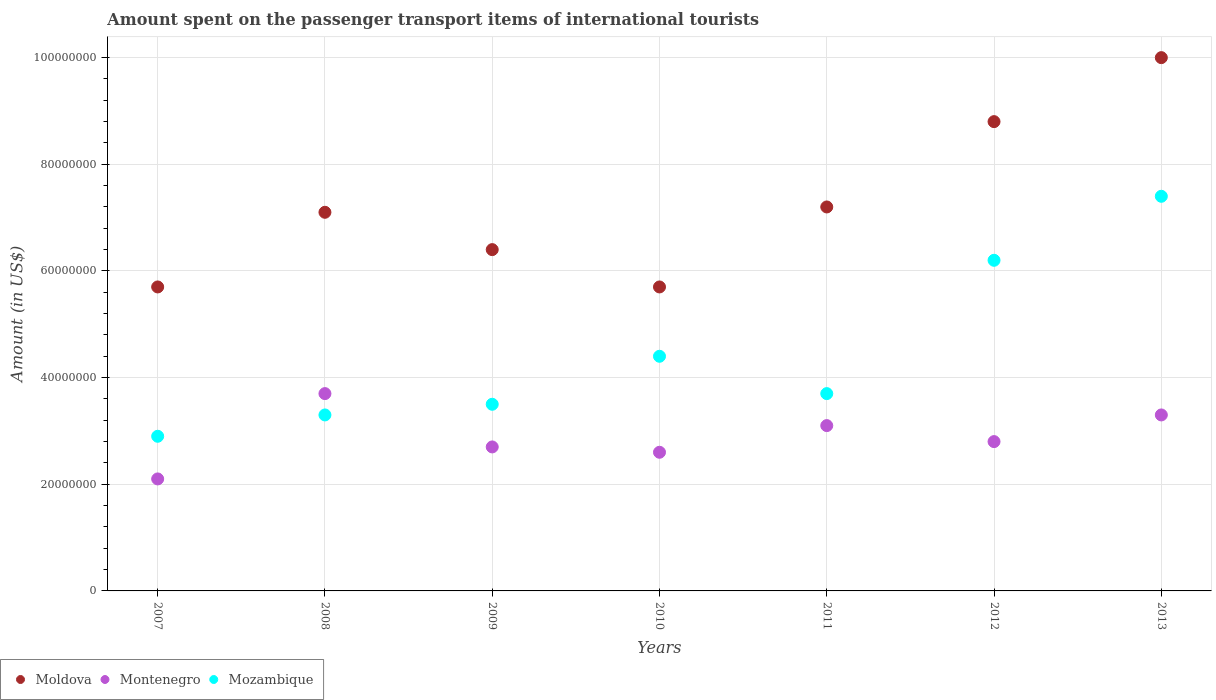Is the number of dotlines equal to the number of legend labels?
Offer a terse response. Yes. What is the amount spent on the passenger transport items of international tourists in Montenegro in 2013?
Keep it short and to the point. 3.30e+07. Across all years, what is the maximum amount spent on the passenger transport items of international tourists in Mozambique?
Offer a very short reply. 7.40e+07. Across all years, what is the minimum amount spent on the passenger transport items of international tourists in Mozambique?
Your answer should be very brief. 2.90e+07. In which year was the amount spent on the passenger transport items of international tourists in Montenegro maximum?
Your answer should be very brief. 2008. In which year was the amount spent on the passenger transport items of international tourists in Montenegro minimum?
Provide a succinct answer. 2007. What is the total amount spent on the passenger transport items of international tourists in Montenegro in the graph?
Provide a succinct answer. 2.03e+08. What is the difference between the amount spent on the passenger transport items of international tourists in Moldova in 2010 and that in 2011?
Offer a terse response. -1.50e+07. What is the difference between the amount spent on the passenger transport items of international tourists in Moldova in 2008 and the amount spent on the passenger transport items of international tourists in Montenegro in 2009?
Provide a succinct answer. 4.40e+07. What is the average amount spent on the passenger transport items of international tourists in Mozambique per year?
Keep it short and to the point. 4.49e+07. In the year 2007, what is the difference between the amount spent on the passenger transport items of international tourists in Mozambique and amount spent on the passenger transport items of international tourists in Montenegro?
Your response must be concise. 8.00e+06. In how many years, is the amount spent on the passenger transport items of international tourists in Mozambique greater than 92000000 US$?
Your answer should be very brief. 0. What is the ratio of the amount spent on the passenger transport items of international tourists in Montenegro in 2008 to that in 2009?
Offer a very short reply. 1.37. Is the amount spent on the passenger transport items of international tourists in Moldova in 2009 less than that in 2012?
Provide a short and direct response. Yes. Is the difference between the amount spent on the passenger transport items of international tourists in Mozambique in 2008 and 2010 greater than the difference between the amount spent on the passenger transport items of international tourists in Montenegro in 2008 and 2010?
Provide a short and direct response. No. What is the difference between the highest and the second highest amount spent on the passenger transport items of international tourists in Moldova?
Your answer should be very brief. 1.20e+07. What is the difference between the highest and the lowest amount spent on the passenger transport items of international tourists in Montenegro?
Offer a very short reply. 1.60e+07. Is the sum of the amount spent on the passenger transport items of international tourists in Mozambique in 2008 and 2009 greater than the maximum amount spent on the passenger transport items of international tourists in Montenegro across all years?
Ensure brevity in your answer.  Yes. Is it the case that in every year, the sum of the amount spent on the passenger transport items of international tourists in Montenegro and amount spent on the passenger transport items of international tourists in Moldova  is greater than the amount spent on the passenger transport items of international tourists in Mozambique?
Offer a very short reply. Yes. Is the amount spent on the passenger transport items of international tourists in Montenegro strictly less than the amount spent on the passenger transport items of international tourists in Mozambique over the years?
Offer a very short reply. No. Does the graph contain any zero values?
Provide a short and direct response. No. Does the graph contain grids?
Your answer should be very brief. Yes. How many legend labels are there?
Your response must be concise. 3. How are the legend labels stacked?
Provide a succinct answer. Horizontal. What is the title of the graph?
Your response must be concise. Amount spent on the passenger transport items of international tourists. What is the Amount (in US$) of Moldova in 2007?
Give a very brief answer. 5.70e+07. What is the Amount (in US$) of Montenegro in 2007?
Ensure brevity in your answer.  2.10e+07. What is the Amount (in US$) of Mozambique in 2007?
Provide a short and direct response. 2.90e+07. What is the Amount (in US$) in Moldova in 2008?
Give a very brief answer. 7.10e+07. What is the Amount (in US$) in Montenegro in 2008?
Offer a terse response. 3.70e+07. What is the Amount (in US$) in Mozambique in 2008?
Make the answer very short. 3.30e+07. What is the Amount (in US$) in Moldova in 2009?
Provide a succinct answer. 6.40e+07. What is the Amount (in US$) of Montenegro in 2009?
Give a very brief answer. 2.70e+07. What is the Amount (in US$) of Mozambique in 2009?
Provide a succinct answer. 3.50e+07. What is the Amount (in US$) in Moldova in 2010?
Offer a terse response. 5.70e+07. What is the Amount (in US$) in Montenegro in 2010?
Your answer should be very brief. 2.60e+07. What is the Amount (in US$) of Mozambique in 2010?
Offer a terse response. 4.40e+07. What is the Amount (in US$) of Moldova in 2011?
Your response must be concise. 7.20e+07. What is the Amount (in US$) in Montenegro in 2011?
Your answer should be compact. 3.10e+07. What is the Amount (in US$) in Mozambique in 2011?
Make the answer very short. 3.70e+07. What is the Amount (in US$) in Moldova in 2012?
Your answer should be compact. 8.80e+07. What is the Amount (in US$) of Montenegro in 2012?
Keep it short and to the point. 2.80e+07. What is the Amount (in US$) in Mozambique in 2012?
Make the answer very short. 6.20e+07. What is the Amount (in US$) in Moldova in 2013?
Keep it short and to the point. 1.00e+08. What is the Amount (in US$) of Montenegro in 2013?
Keep it short and to the point. 3.30e+07. What is the Amount (in US$) of Mozambique in 2013?
Your answer should be very brief. 7.40e+07. Across all years, what is the maximum Amount (in US$) in Montenegro?
Offer a terse response. 3.70e+07. Across all years, what is the maximum Amount (in US$) of Mozambique?
Offer a very short reply. 7.40e+07. Across all years, what is the minimum Amount (in US$) in Moldova?
Give a very brief answer. 5.70e+07. Across all years, what is the minimum Amount (in US$) of Montenegro?
Your answer should be very brief. 2.10e+07. Across all years, what is the minimum Amount (in US$) of Mozambique?
Offer a very short reply. 2.90e+07. What is the total Amount (in US$) of Moldova in the graph?
Give a very brief answer. 5.09e+08. What is the total Amount (in US$) in Montenegro in the graph?
Your answer should be compact. 2.03e+08. What is the total Amount (in US$) of Mozambique in the graph?
Provide a succinct answer. 3.14e+08. What is the difference between the Amount (in US$) of Moldova in 2007 and that in 2008?
Offer a terse response. -1.40e+07. What is the difference between the Amount (in US$) of Montenegro in 2007 and that in 2008?
Keep it short and to the point. -1.60e+07. What is the difference between the Amount (in US$) of Mozambique in 2007 and that in 2008?
Offer a very short reply. -4.00e+06. What is the difference between the Amount (in US$) in Moldova in 2007 and that in 2009?
Your answer should be very brief. -7.00e+06. What is the difference between the Amount (in US$) of Montenegro in 2007 and that in 2009?
Make the answer very short. -6.00e+06. What is the difference between the Amount (in US$) in Mozambique in 2007 and that in 2009?
Make the answer very short. -6.00e+06. What is the difference between the Amount (in US$) in Montenegro in 2007 and that in 2010?
Your response must be concise. -5.00e+06. What is the difference between the Amount (in US$) in Mozambique in 2007 and that in 2010?
Ensure brevity in your answer.  -1.50e+07. What is the difference between the Amount (in US$) in Moldova in 2007 and that in 2011?
Provide a short and direct response. -1.50e+07. What is the difference between the Amount (in US$) of Montenegro in 2007 and that in 2011?
Provide a short and direct response. -1.00e+07. What is the difference between the Amount (in US$) of Mozambique in 2007 and that in 2011?
Ensure brevity in your answer.  -8.00e+06. What is the difference between the Amount (in US$) of Moldova in 2007 and that in 2012?
Your response must be concise. -3.10e+07. What is the difference between the Amount (in US$) in Montenegro in 2007 and that in 2012?
Offer a very short reply. -7.00e+06. What is the difference between the Amount (in US$) of Mozambique in 2007 and that in 2012?
Ensure brevity in your answer.  -3.30e+07. What is the difference between the Amount (in US$) in Moldova in 2007 and that in 2013?
Ensure brevity in your answer.  -4.30e+07. What is the difference between the Amount (in US$) in Montenegro in 2007 and that in 2013?
Make the answer very short. -1.20e+07. What is the difference between the Amount (in US$) in Mozambique in 2007 and that in 2013?
Make the answer very short. -4.50e+07. What is the difference between the Amount (in US$) of Moldova in 2008 and that in 2009?
Offer a very short reply. 7.00e+06. What is the difference between the Amount (in US$) in Moldova in 2008 and that in 2010?
Ensure brevity in your answer.  1.40e+07. What is the difference between the Amount (in US$) of Montenegro in 2008 and that in 2010?
Provide a short and direct response. 1.10e+07. What is the difference between the Amount (in US$) of Mozambique in 2008 and that in 2010?
Make the answer very short. -1.10e+07. What is the difference between the Amount (in US$) in Moldova in 2008 and that in 2012?
Keep it short and to the point. -1.70e+07. What is the difference between the Amount (in US$) of Montenegro in 2008 and that in 2012?
Your response must be concise. 9.00e+06. What is the difference between the Amount (in US$) in Mozambique in 2008 and that in 2012?
Make the answer very short. -2.90e+07. What is the difference between the Amount (in US$) in Moldova in 2008 and that in 2013?
Your answer should be compact. -2.90e+07. What is the difference between the Amount (in US$) of Mozambique in 2008 and that in 2013?
Provide a short and direct response. -4.10e+07. What is the difference between the Amount (in US$) of Mozambique in 2009 and that in 2010?
Give a very brief answer. -9.00e+06. What is the difference between the Amount (in US$) of Moldova in 2009 and that in 2011?
Your answer should be compact. -8.00e+06. What is the difference between the Amount (in US$) of Moldova in 2009 and that in 2012?
Your response must be concise. -2.40e+07. What is the difference between the Amount (in US$) in Mozambique in 2009 and that in 2012?
Provide a short and direct response. -2.70e+07. What is the difference between the Amount (in US$) in Moldova in 2009 and that in 2013?
Provide a short and direct response. -3.60e+07. What is the difference between the Amount (in US$) in Montenegro in 2009 and that in 2013?
Keep it short and to the point. -6.00e+06. What is the difference between the Amount (in US$) in Mozambique in 2009 and that in 2013?
Make the answer very short. -3.90e+07. What is the difference between the Amount (in US$) in Moldova in 2010 and that in 2011?
Your response must be concise. -1.50e+07. What is the difference between the Amount (in US$) of Montenegro in 2010 and that in 2011?
Offer a very short reply. -5.00e+06. What is the difference between the Amount (in US$) of Mozambique in 2010 and that in 2011?
Ensure brevity in your answer.  7.00e+06. What is the difference between the Amount (in US$) in Moldova in 2010 and that in 2012?
Provide a succinct answer. -3.10e+07. What is the difference between the Amount (in US$) in Mozambique in 2010 and that in 2012?
Your answer should be compact. -1.80e+07. What is the difference between the Amount (in US$) in Moldova in 2010 and that in 2013?
Provide a short and direct response. -4.30e+07. What is the difference between the Amount (in US$) in Montenegro in 2010 and that in 2013?
Provide a short and direct response. -7.00e+06. What is the difference between the Amount (in US$) of Mozambique in 2010 and that in 2013?
Offer a very short reply. -3.00e+07. What is the difference between the Amount (in US$) of Moldova in 2011 and that in 2012?
Offer a very short reply. -1.60e+07. What is the difference between the Amount (in US$) of Montenegro in 2011 and that in 2012?
Provide a short and direct response. 3.00e+06. What is the difference between the Amount (in US$) in Mozambique in 2011 and that in 2012?
Ensure brevity in your answer.  -2.50e+07. What is the difference between the Amount (in US$) of Moldova in 2011 and that in 2013?
Your answer should be compact. -2.80e+07. What is the difference between the Amount (in US$) of Mozambique in 2011 and that in 2013?
Provide a succinct answer. -3.70e+07. What is the difference between the Amount (in US$) of Moldova in 2012 and that in 2013?
Keep it short and to the point. -1.20e+07. What is the difference between the Amount (in US$) of Montenegro in 2012 and that in 2013?
Offer a very short reply. -5.00e+06. What is the difference between the Amount (in US$) of Mozambique in 2012 and that in 2013?
Make the answer very short. -1.20e+07. What is the difference between the Amount (in US$) in Moldova in 2007 and the Amount (in US$) in Mozambique in 2008?
Your response must be concise. 2.40e+07. What is the difference between the Amount (in US$) of Montenegro in 2007 and the Amount (in US$) of Mozambique in 2008?
Your answer should be compact. -1.20e+07. What is the difference between the Amount (in US$) of Moldova in 2007 and the Amount (in US$) of Montenegro in 2009?
Offer a terse response. 3.00e+07. What is the difference between the Amount (in US$) of Moldova in 2007 and the Amount (in US$) of Mozambique in 2009?
Offer a terse response. 2.20e+07. What is the difference between the Amount (in US$) of Montenegro in 2007 and the Amount (in US$) of Mozambique in 2009?
Offer a very short reply. -1.40e+07. What is the difference between the Amount (in US$) of Moldova in 2007 and the Amount (in US$) of Montenegro in 2010?
Offer a terse response. 3.10e+07. What is the difference between the Amount (in US$) of Moldova in 2007 and the Amount (in US$) of Mozambique in 2010?
Offer a terse response. 1.30e+07. What is the difference between the Amount (in US$) of Montenegro in 2007 and the Amount (in US$) of Mozambique in 2010?
Keep it short and to the point. -2.30e+07. What is the difference between the Amount (in US$) in Moldova in 2007 and the Amount (in US$) in Montenegro in 2011?
Your answer should be compact. 2.60e+07. What is the difference between the Amount (in US$) in Moldova in 2007 and the Amount (in US$) in Mozambique in 2011?
Keep it short and to the point. 2.00e+07. What is the difference between the Amount (in US$) in Montenegro in 2007 and the Amount (in US$) in Mozambique in 2011?
Provide a short and direct response. -1.60e+07. What is the difference between the Amount (in US$) of Moldova in 2007 and the Amount (in US$) of Montenegro in 2012?
Keep it short and to the point. 2.90e+07. What is the difference between the Amount (in US$) in Moldova in 2007 and the Amount (in US$) in Mozambique in 2012?
Ensure brevity in your answer.  -5.00e+06. What is the difference between the Amount (in US$) of Montenegro in 2007 and the Amount (in US$) of Mozambique in 2012?
Your response must be concise. -4.10e+07. What is the difference between the Amount (in US$) in Moldova in 2007 and the Amount (in US$) in Montenegro in 2013?
Your answer should be compact. 2.40e+07. What is the difference between the Amount (in US$) of Moldova in 2007 and the Amount (in US$) of Mozambique in 2013?
Make the answer very short. -1.70e+07. What is the difference between the Amount (in US$) of Montenegro in 2007 and the Amount (in US$) of Mozambique in 2013?
Make the answer very short. -5.30e+07. What is the difference between the Amount (in US$) of Moldova in 2008 and the Amount (in US$) of Montenegro in 2009?
Provide a short and direct response. 4.40e+07. What is the difference between the Amount (in US$) in Moldova in 2008 and the Amount (in US$) in Mozambique in 2009?
Your answer should be very brief. 3.60e+07. What is the difference between the Amount (in US$) in Moldova in 2008 and the Amount (in US$) in Montenegro in 2010?
Your answer should be very brief. 4.50e+07. What is the difference between the Amount (in US$) in Moldova in 2008 and the Amount (in US$) in Mozambique in 2010?
Your answer should be compact. 2.70e+07. What is the difference between the Amount (in US$) of Montenegro in 2008 and the Amount (in US$) of Mozambique in 2010?
Make the answer very short. -7.00e+06. What is the difference between the Amount (in US$) in Moldova in 2008 and the Amount (in US$) in Montenegro in 2011?
Your response must be concise. 4.00e+07. What is the difference between the Amount (in US$) in Moldova in 2008 and the Amount (in US$) in Mozambique in 2011?
Offer a very short reply. 3.40e+07. What is the difference between the Amount (in US$) in Moldova in 2008 and the Amount (in US$) in Montenegro in 2012?
Your answer should be very brief. 4.30e+07. What is the difference between the Amount (in US$) in Moldova in 2008 and the Amount (in US$) in Mozambique in 2012?
Provide a succinct answer. 9.00e+06. What is the difference between the Amount (in US$) of Montenegro in 2008 and the Amount (in US$) of Mozambique in 2012?
Your answer should be compact. -2.50e+07. What is the difference between the Amount (in US$) in Moldova in 2008 and the Amount (in US$) in Montenegro in 2013?
Give a very brief answer. 3.80e+07. What is the difference between the Amount (in US$) in Moldova in 2008 and the Amount (in US$) in Mozambique in 2013?
Your answer should be compact. -3.00e+06. What is the difference between the Amount (in US$) in Montenegro in 2008 and the Amount (in US$) in Mozambique in 2013?
Offer a very short reply. -3.70e+07. What is the difference between the Amount (in US$) in Moldova in 2009 and the Amount (in US$) in Montenegro in 2010?
Your answer should be very brief. 3.80e+07. What is the difference between the Amount (in US$) in Moldova in 2009 and the Amount (in US$) in Mozambique in 2010?
Offer a terse response. 2.00e+07. What is the difference between the Amount (in US$) in Montenegro in 2009 and the Amount (in US$) in Mozambique in 2010?
Give a very brief answer. -1.70e+07. What is the difference between the Amount (in US$) of Moldova in 2009 and the Amount (in US$) of Montenegro in 2011?
Your answer should be very brief. 3.30e+07. What is the difference between the Amount (in US$) of Moldova in 2009 and the Amount (in US$) of Mozambique in 2011?
Make the answer very short. 2.70e+07. What is the difference between the Amount (in US$) in Montenegro in 2009 and the Amount (in US$) in Mozambique in 2011?
Offer a very short reply. -1.00e+07. What is the difference between the Amount (in US$) in Moldova in 2009 and the Amount (in US$) in Montenegro in 2012?
Your answer should be compact. 3.60e+07. What is the difference between the Amount (in US$) of Montenegro in 2009 and the Amount (in US$) of Mozambique in 2012?
Offer a terse response. -3.50e+07. What is the difference between the Amount (in US$) of Moldova in 2009 and the Amount (in US$) of Montenegro in 2013?
Ensure brevity in your answer.  3.10e+07. What is the difference between the Amount (in US$) of Moldova in 2009 and the Amount (in US$) of Mozambique in 2013?
Make the answer very short. -1.00e+07. What is the difference between the Amount (in US$) of Montenegro in 2009 and the Amount (in US$) of Mozambique in 2013?
Offer a terse response. -4.70e+07. What is the difference between the Amount (in US$) in Moldova in 2010 and the Amount (in US$) in Montenegro in 2011?
Make the answer very short. 2.60e+07. What is the difference between the Amount (in US$) in Montenegro in 2010 and the Amount (in US$) in Mozambique in 2011?
Offer a very short reply. -1.10e+07. What is the difference between the Amount (in US$) of Moldova in 2010 and the Amount (in US$) of Montenegro in 2012?
Your answer should be very brief. 2.90e+07. What is the difference between the Amount (in US$) in Moldova in 2010 and the Amount (in US$) in Mozambique in 2012?
Give a very brief answer. -5.00e+06. What is the difference between the Amount (in US$) in Montenegro in 2010 and the Amount (in US$) in Mozambique in 2012?
Offer a terse response. -3.60e+07. What is the difference between the Amount (in US$) in Moldova in 2010 and the Amount (in US$) in Montenegro in 2013?
Provide a succinct answer. 2.40e+07. What is the difference between the Amount (in US$) of Moldova in 2010 and the Amount (in US$) of Mozambique in 2013?
Give a very brief answer. -1.70e+07. What is the difference between the Amount (in US$) of Montenegro in 2010 and the Amount (in US$) of Mozambique in 2013?
Your answer should be very brief. -4.80e+07. What is the difference between the Amount (in US$) in Moldova in 2011 and the Amount (in US$) in Montenegro in 2012?
Your response must be concise. 4.40e+07. What is the difference between the Amount (in US$) in Moldova in 2011 and the Amount (in US$) in Mozambique in 2012?
Keep it short and to the point. 1.00e+07. What is the difference between the Amount (in US$) of Montenegro in 2011 and the Amount (in US$) of Mozambique in 2012?
Keep it short and to the point. -3.10e+07. What is the difference between the Amount (in US$) in Moldova in 2011 and the Amount (in US$) in Montenegro in 2013?
Your answer should be compact. 3.90e+07. What is the difference between the Amount (in US$) of Montenegro in 2011 and the Amount (in US$) of Mozambique in 2013?
Provide a succinct answer. -4.30e+07. What is the difference between the Amount (in US$) in Moldova in 2012 and the Amount (in US$) in Montenegro in 2013?
Ensure brevity in your answer.  5.50e+07. What is the difference between the Amount (in US$) of Moldova in 2012 and the Amount (in US$) of Mozambique in 2013?
Keep it short and to the point. 1.40e+07. What is the difference between the Amount (in US$) of Montenegro in 2012 and the Amount (in US$) of Mozambique in 2013?
Your response must be concise. -4.60e+07. What is the average Amount (in US$) of Moldova per year?
Offer a very short reply. 7.27e+07. What is the average Amount (in US$) in Montenegro per year?
Offer a very short reply. 2.90e+07. What is the average Amount (in US$) in Mozambique per year?
Provide a succinct answer. 4.49e+07. In the year 2007, what is the difference between the Amount (in US$) of Moldova and Amount (in US$) of Montenegro?
Offer a very short reply. 3.60e+07. In the year 2007, what is the difference between the Amount (in US$) of Moldova and Amount (in US$) of Mozambique?
Keep it short and to the point. 2.80e+07. In the year 2007, what is the difference between the Amount (in US$) in Montenegro and Amount (in US$) in Mozambique?
Give a very brief answer. -8.00e+06. In the year 2008, what is the difference between the Amount (in US$) of Moldova and Amount (in US$) of Montenegro?
Your response must be concise. 3.40e+07. In the year 2008, what is the difference between the Amount (in US$) of Moldova and Amount (in US$) of Mozambique?
Your response must be concise. 3.80e+07. In the year 2009, what is the difference between the Amount (in US$) in Moldova and Amount (in US$) in Montenegro?
Provide a succinct answer. 3.70e+07. In the year 2009, what is the difference between the Amount (in US$) in Moldova and Amount (in US$) in Mozambique?
Offer a terse response. 2.90e+07. In the year 2009, what is the difference between the Amount (in US$) in Montenegro and Amount (in US$) in Mozambique?
Keep it short and to the point. -8.00e+06. In the year 2010, what is the difference between the Amount (in US$) of Moldova and Amount (in US$) of Montenegro?
Your answer should be compact. 3.10e+07. In the year 2010, what is the difference between the Amount (in US$) of Moldova and Amount (in US$) of Mozambique?
Offer a terse response. 1.30e+07. In the year 2010, what is the difference between the Amount (in US$) of Montenegro and Amount (in US$) of Mozambique?
Provide a short and direct response. -1.80e+07. In the year 2011, what is the difference between the Amount (in US$) of Moldova and Amount (in US$) of Montenegro?
Offer a very short reply. 4.10e+07. In the year 2011, what is the difference between the Amount (in US$) in Moldova and Amount (in US$) in Mozambique?
Your answer should be very brief. 3.50e+07. In the year 2011, what is the difference between the Amount (in US$) in Montenegro and Amount (in US$) in Mozambique?
Offer a very short reply. -6.00e+06. In the year 2012, what is the difference between the Amount (in US$) in Moldova and Amount (in US$) in Montenegro?
Offer a terse response. 6.00e+07. In the year 2012, what is the difference between the Amount (in US$) of Moldova and Amount (in US$) of Mozambique?
Your answer should be very brief. 2.60e+07. In the year 2012, what is the difference between the Amount (in US$) in Montenegro and Amount (in US$) in Mozambique?
Your answer should be very brief. -3.40e+07. In the year 2013, what is the difference between the Amount (in US$) in Moldova and Amount (in US$) in Montenegro?
Keep it short and to the point. 6.70e+07. In the year 2013, what is the difference between the Amount (in US$) in Moldova and Amount (in US$) in Mozambique?
Your response must be concise. 2.60e+07. In the year 2013, what is the difference between the Amount (in US$) in Montenegro and Amount (in US$) in Mozambique?
Offer a very short reply. -4.10e+07. What is the ratio of the Amount (in US$) in Moldova in 2007 to that in 2008?
Ensure brevity in your answer.  0.8. What is the ratio of the Amount (in US$) of Montenegro in 2007 to that in 2008?
Your response must be concise. 0.57. What is the ratio of the Amount (in US$) in Mozambique in 2007 to that in 2008?
Provide a short and direct response. 0.88. What is the ratio of the Amount (in US$) of Moldova in 2007 to that in 2009?
Your response must be concise. 0.89. What is the ratio of the Amount (in US$) of Mozambique in 2007 to that in 2009?
Provide a succinct answer. 0.83. What is the ratio of the Amount (in US$) in Montenegro in 2007 to that in 2010?
Make the answer very short. 0.81. What is the ratio of the Amount (in US$) in Mozambique in 2007 to that in 2010?
Offer a very short reply. 0.66. What is the ratio of the Amount (in US$) of Moldova in 2007 to that in 2011?
Your response must be concise. 0.79. What is the ratio of the Amount (in US$) in Montenegro in 2007 to that in 2011?
Give a very brief answer. 0.68. What is the ratio of the Amount (in US$) in Mozambique in 2007 to that in 2011?
Provide a succinct answer. 0.78. What is the ratio of the Amount (in US$) in Moldova in 2007 to that in 2012?
Give a very brief answer. 0.65. What is the ratio of the Amount (in US$) in Mozambique in 2007 to that in 2012?
Provide a succinct answer. 0.47. What is the ratio of the Amount (in US$) of Moldova in 2007 to that in 2013?
Your answer should be very brief. 0.57. What is the ratio of the Amount (in US$) of Montenegro in 2007 to that in 2013?
Your answer should be very brief. 0.64. What is the ratio of the Amount (in US$) in Mozambique in 2007 to that in 2013?
Offer a very short reply. 0.39. What is the ratio of the Amount (in US$) in Moldova in 2008 to that in 2009?
Ensure brevity in your answer.  1.11. What is the ratio of the Amount (in US$) in Montenegro in 2008 to that in 2009?
Give a very brief answer. 1.37. What is the ratio of the Amount (in US$) of Mozambique in 2008 to that in 2009?
Ensure brevity in your answer.  0.94. What is the ratio of the Amount (in US$) in Moldova in 2008 to that in 2010?
Offer a very short reply. 1.25. What is the ratio of the Amount (in US$) of Montenegro in 2008 to that in 2010?
Offer a very short reply. 1.42. What is the ratio of the Amount (in US$) of Mozambique in 2008 to that in 2010?
Provide a succinct answer. 0.75. What is the ratio of the Amount (in US$) in Moldova in 2008 to that in 2011?
Offer a very short reply. 0.99. What is the ratio of the Amount (in US$) of Montenegro in 2008 to that in 2011?
Your response must be concise. 1.19. What is the ratio of the Amount (in US$) of Mozambique in 2008 to that in 2011?
Make the answer very short. 0.89. What is the ratio of the Amount (in US$) in Moldova in 2008 to that in 2012?
Provide a short and direct response. 0.81. What is the ratio of the Amount (in US$) in Montenegro in 2008 to that in 2012?
Provide a short and direct response. 1.32. What is the ratio of the Amount (in US$) in Mozambique in 2008 to that in 2012?
Provide a succinct answer. 0.53. What is the ratio of the Amount (in US$) of Moldova in 2008 to that in 2013?
Ensure brevity in your answer.  0.71. What is the ratio of the Amount (in US$) in Montenegro in 2008 to that in 2013?
Your answer should be compact. 1.12. What is the ratio of the Amount (in US$) of Mozambique in 2008 to that in 2013?
Offer a terse response. 0.45. What is the ratio of the Amount (in US$) in Moldova in 2009 to that in 2010?
Offer a terse response. 1.12. What is the ratio of the Amount (in US$) of Montenegro in 2009 to that in 2010?
Your answer should be very brief. 1.04. What is the ratio of the Amount (in US$) in Mozambique in 2009 to that in 2010?
Your answer should be compact. 0.8. What is the ratio of the Amount (in US$) in Moldova in 2009 to that in 2011?
Your answer should be compact. 0.89. What is the ratio of the Amount (in US$) in Montenegro in 2009 to that in 2011?
Your response must be concise. 0.87. What is the ratio of the Amount (in US$) of Mozambique in 2009 to that in 2011?
Your response must be concise. 0.95. What is the ratio of the Amount (in US$) in Moldova in 2009 to that in 2012?
Keep it short and to the point. 0.73. What is the ratio of the Amount (in US$) of Mozambique in 2009 to that in 2012?
Give a very brief answer. 0.56. What is the ratio of the Amount (in US$) of Moldova in 2009 to that in 2013?
Offer a terse response. 0.64. What is the ratio of the Amount (in US$) of Montenegro in 2009 to that in 2013?
Offer a terse response. 0.82. What is the ratio of the Amount (in US$) of Mozambique in 2009 to that in 2013?
Offer a very short reply. 0.47. What is the ratio of the Amount (in US$) of Moldova in 2010 to that in 2011?
Your response must be concise. 0.79. What is the ratio of the Amount (in US$) of Montenegro in 2010 to that in 2011?
Ensure brevity in your answer.  0.84. What is the ratio of the Amount (in US$) in Mozambique in 2010 to that in 2011?
Your answer should be compact. 1.19. What is the ratio of the Amount (in US$) of Moldova in 2010 to that in 2012?
Ensure brevity in your answer.  0.65. What is the ratio of the Amount (in US$) in Montenegro in 2010 to that in 2012?
Ensure brevity in your answer.  0.93. What is the ratio of the Amount (in US$) in Mozambique in 2010 to that in 2012?
Provide a succinct answer. 0.71. What is the ratio of the Amount (in US$) in Moldova in 2010 to that in 2013?
Ensure brevity in your answer.  0.57. What is the ratio of the Amount (in US$) of Montenegro in 2010 to that in 2013?
Your answer should be compact. 0.79. What is the ratio of the Amount (in US$) of Mozambique in 2010 to that in 2013?
Your answer should be compact. 0.59. What is the ratio of the Amount (in US$) of Moldova in 2011 to that in 2012?
Your response must be concise. 0.82. What is the ratio of the Amount (in US$) of Montenegro in 2011 to that in 2012?
Provide a short and direct response. 1.11. What is the ratio of the Amount (in US$) in Mozambique in 2011 to that in 2012?
Your answer should be compact. 0.6. What is the ratio of the Amount (in US$) in Moldova in 2011 to that in 2013?
Ensure brevity in your answer.  0.72. What is the ratio of the Amount (in US$) of Montenegro in 2011 to that in 2013?
Make the answer very short. 0.94. What is the ratio of the Amount (in US$) in Montenegro in 2012 to that in 2013?
Make the answer very short. 0.85. What is the ratio of the Amount (in US$) in Mozambique in 2012 to that in 2013?
Keep it short and to the point. 0.84. What is the difference between the highest and the second highest Amount (in US$) in Moldova?
Provide a short and direct response. 1.20e+07. What is the difference between the highest and the second highest Amount (in US$) in Montenegro?
Your answer should be compact. 4.00e+06. What is the difference between the highest and the second highest Amount (in US$) in Mozambique?
Make the answer very short. 1.20e+07. What is the difference between the highest and the lowest Amount (in US$) of Moldova?
Offer a terse response. 4.30e+07. What is the difference between the highest and the lowest Amount (in US$) of Montenegro?
Your answer should be very brief. 1.60e+07. What is the difference between the highest and the lowest Amount (in US$) of Mozambique?
Your answer should be very brief. 4.50e+07. 